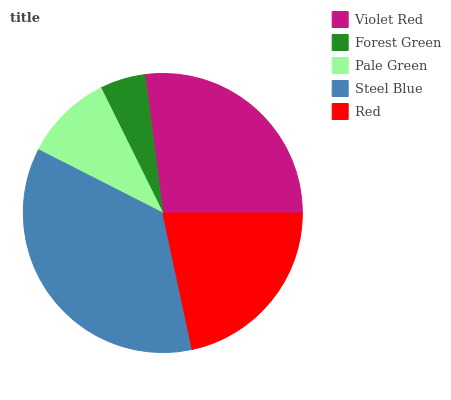Is Forest Green the minimum?
Answer yes or no. Yes. Is Steel Blue the maximum?
Answer yes or no. Yes. Is Pale Green the minimum?
Answer yes or no. No. Is Pale Green the maximum?
Answer yes or no. No. Is Pale Green greater than Forest Green?
Answer yes or no. Yes. Is Forest Green less than Pale Green?
Answer yes or no. Yes. Is Forest Green greater than Pale Green?
Answer yes or no. No. Is Pale Green less than Forest Green?
Answer yes or no. No. Is Red the high median?
Answer yes or no. Yes. Is Red the low median?
Answer yes or no. Yes. Is Forest Green the high median?
Answer yes or no. No. Is Pale Green the low median?
Answer yes or no. No. 